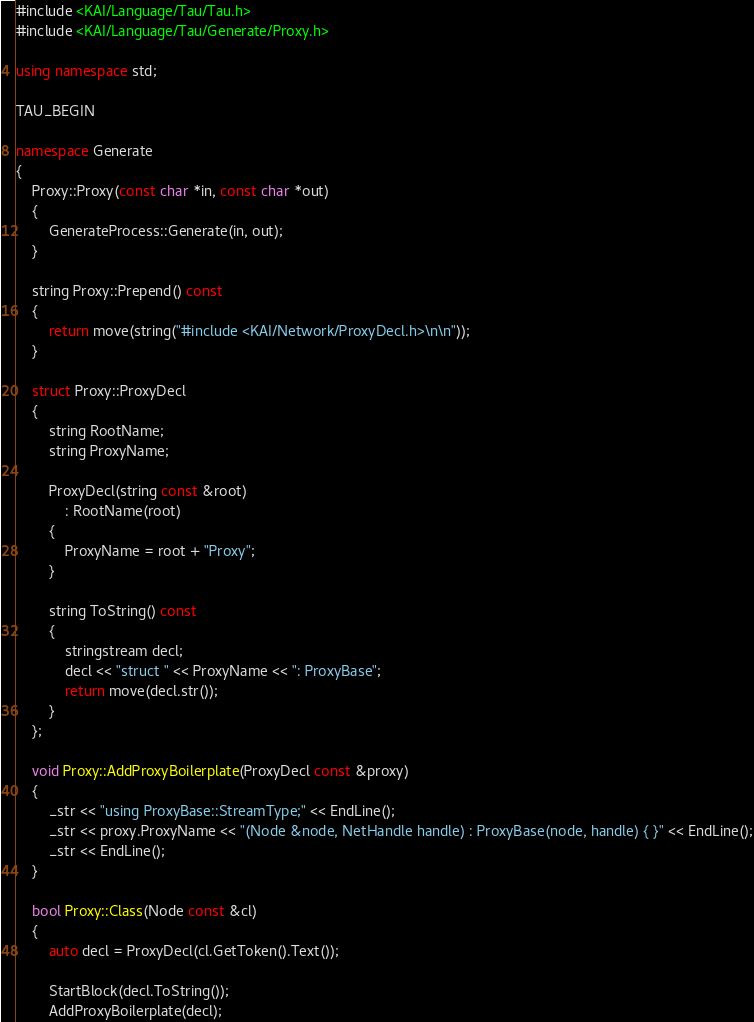Convert code to text. <code><loc_0><loc_0><loc_500><loc_500><_C++_>#include <KAI/Language/Tau/Tau.h>
#include <KAI/Language/Tau/Generate/Proxy.h>

using namespace std;

TAU_BEGIN

namespace Generate
{
	Proxy::Proxy(const char *in, const char *out)
	{
		GenerateProcess::Generate(in, out);
	}

	string Proxy::Prepend() const
	{
		return move(string("#include <KAI/Network/ProxyDecl.h>\n\n"));
	}

	struct Proxy::ProxyDecl
	{
		string RootName;
		string ProxyName;

		ProxyDecl(string const &root)
			: RootName(root)
		{
			ProxyName = root + "Proxy";
		}

		string ToString() const
		{
			stringstream decl;
			decl << "struct " << ProxyName << ": ProxyBase";
			return move(decl.str());
		}
	};

	void Proxy::AddProxyBoilerplate(ProxyDecl const &proxy)
	{
		_str << "using ProxyBase::StreamType;" << EndLine();
		_str << proxy.ProxyName << "(Node &node, NetHandle handle) : ProxyBase(node, handle) { }" << EndLine();
		_str << EndLine();
	}

	bool Proxy::Class(Node const &cl)
	{
		auto decl = ProxyDecl(cl.GetToken().Text());

		StartBlock(decl.ToString());
		AddProxyBoilerplate(decl);
</code> 